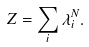<formula> <loc_0><loc_0><loc_500><loc_500>Z = \sum _ { i } \lambda _ { i } ^ { N } .</formula> 